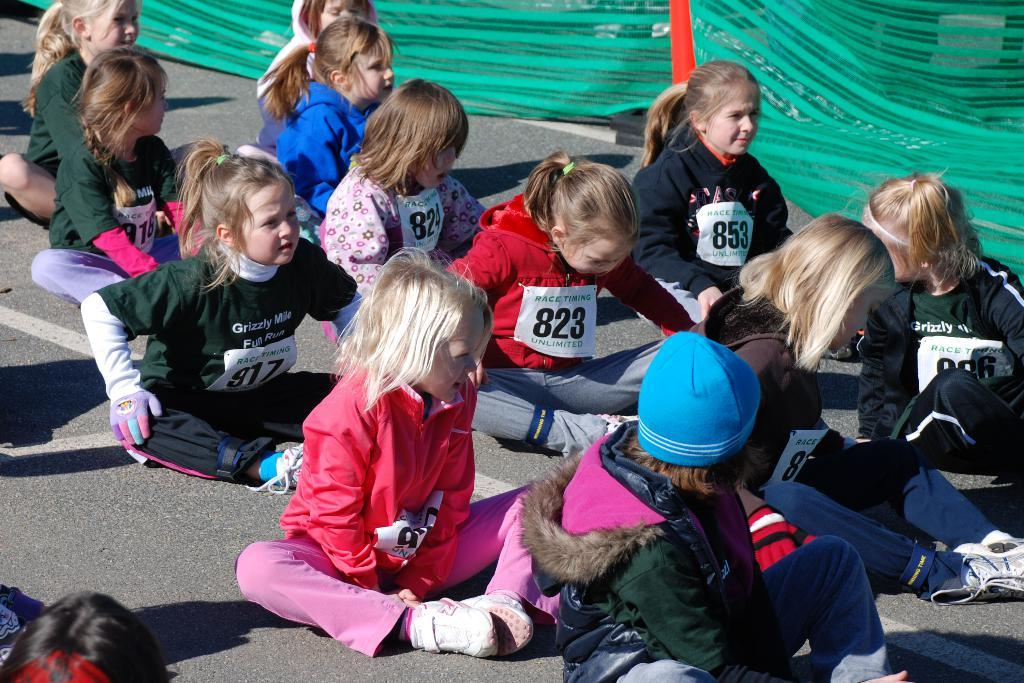What color is the cloth on the right side of the image? The cloth on the right side of the image is green. What are the children doing in the image? The children are sitting on the road in the image. What can be seen on the children's dresses? The children have sticky notes with number digits on their dresses. What type of straw is being used by the children in the image? There is no straw present in the image. What advice are the children giving to each other in the image? There is no indication of the children giving advice to each other in the image. 